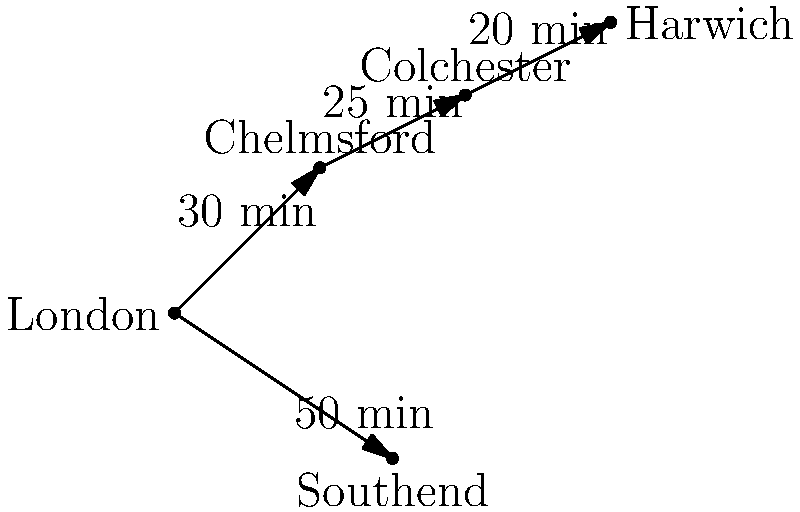Based on the train network diagram, which Essex destination requires changing trains in Colchester when travelling from London? To answer this question, let's analyze the train routes shown in the diagram:

1. We can see that London is directly connected to Chelmsford and Southend.
2. From Chelmsford, there's a direct connection to Colchester.
3. Colchester is then connected to Harwich.
4. There's no direct connection shown between London and Harwich.

Therefore, to reach Harwich from London:
1. You would first take a train from London to Chelmsford (30 minutes).
2. Then from Chelmsford to Colchester (25 minutes).
3. Finally, you would change trains in Colchester to reach Harwich (20 minutes).

Harwich is the only destination that requires changing trains in Colchester when travelling from London, according to this network diagram.
Answer: Harwich 